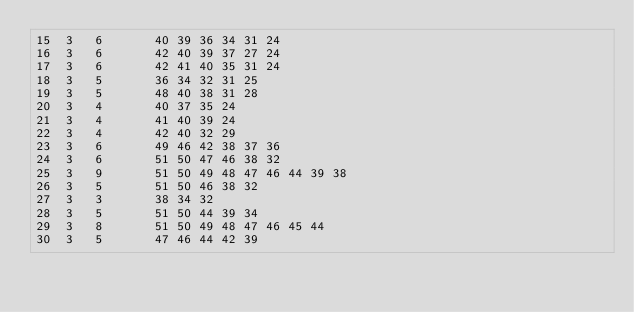Convert code to text. <code><loc_0><loc_0><loc_500><loc_500><_ObjectiveC_>15	3	6		40 39 36 34 31 24 
16	3	6		42 40 39 37 27 24 
17	3	6		42 41 40 35 31 24 
18	3	5		36 34 32 31 25 
19	3	5		48 40 38 31 28 
20	3	4		40 37 35 24 
21	3	4		41 40 39 24 
22	3	4		42 40 32 29 
23	3	6		49 46 42 38 37 36 
24	3	6		51 50 47 46 38 32 
25	3	9		51 50 49 48 47 46 44 39 38 
26	3	5		51 50 46 38 32 
27	3	3		38 34 32 
28	3	5		51 50 44 39 34 
29	3	8		51 50 49 48 47 46 45 44 
30	3	5		47 46 44 42 39 </code> 